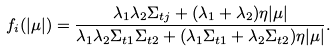<formula> <loc_0><loc_0><loc_500><loc_500>f _ { i } ( | \mu | ) = \frac { \lambda _ { 1 } \lambda _ { 2 } \Sigma _ { t j } + ( \lambda _ { 1 } + \lambda _ { 2 } ) \eta | \mu | } { \lambda _ { 1 } \lambda _ { 2 } \Sigma _ { t 1 } \Sigma _ { t 2 } + ( \lambda _ { 1 } \Sigma _ { t 1 } + \lambda _ { 2 } \Sigma _ { t 2 } ) \eta | \mu | } .</formula> 